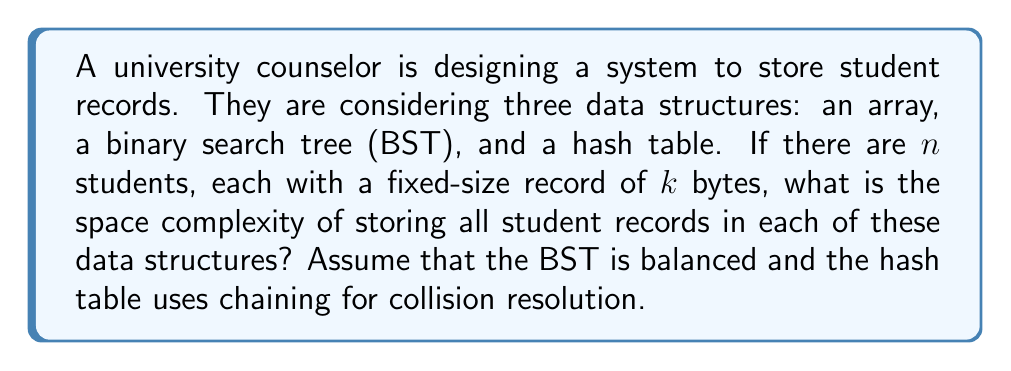Can you solve this math problem? To determine the space complexity for each data structure, we need to consider both the space required for storing the actual student records and any additional overhead associated with the data structure.

1. Array:
   - An array stores elements contiguously in memory.
   - Space required for student records: $O(nk)$
   - No additional overhead
   - Total space complexity: $O(nk)$

2. Binary Search Tree (BST):
   - Each node in a BST contains the student record and two pointers (left and right child).
   - Space required for student records: $O(nk)$
   - Space for pointers: $O(n)$ (2 pointers per node, each typically 4 or 8 bytes)
   - Total space complexity: $O(nk + n) = O(nk)$ (assuming $k > 1$)

3. Hash Table with Chaining:
   - The hash table consists of an array of buckets, each containing a linked list of elements.
   - Space required for student records: $O(nk)$
   - Space for the array of buckets: $O(m)$, where $m$ is the number of buckets
   - Space for linked list nodes: $O(n)$ (each node has a next pointer)
   - Total space complexity: $O(nk + m + n) = O(nk + m)$

   Note: The number of buckets $m$ is often chosen to be proportional to $n$ (e.g., $m = n/\alpha$, where $\alpha$ is the load factor). In this case, the space complexity simplifies to $O(nk)$.

In all three cases, the dominant term is $O(nk)$, which represents the space required to store the actual student records. The additional overhead for the BST and hash table does not change the overall space complexity when $k > 1$.
Answer: The space complexity for storing $n$ student records, each of size $k$ bytes, is $O(nk)$ for all three data structures: array, balanced binary search tree, and hash table with chaining. 